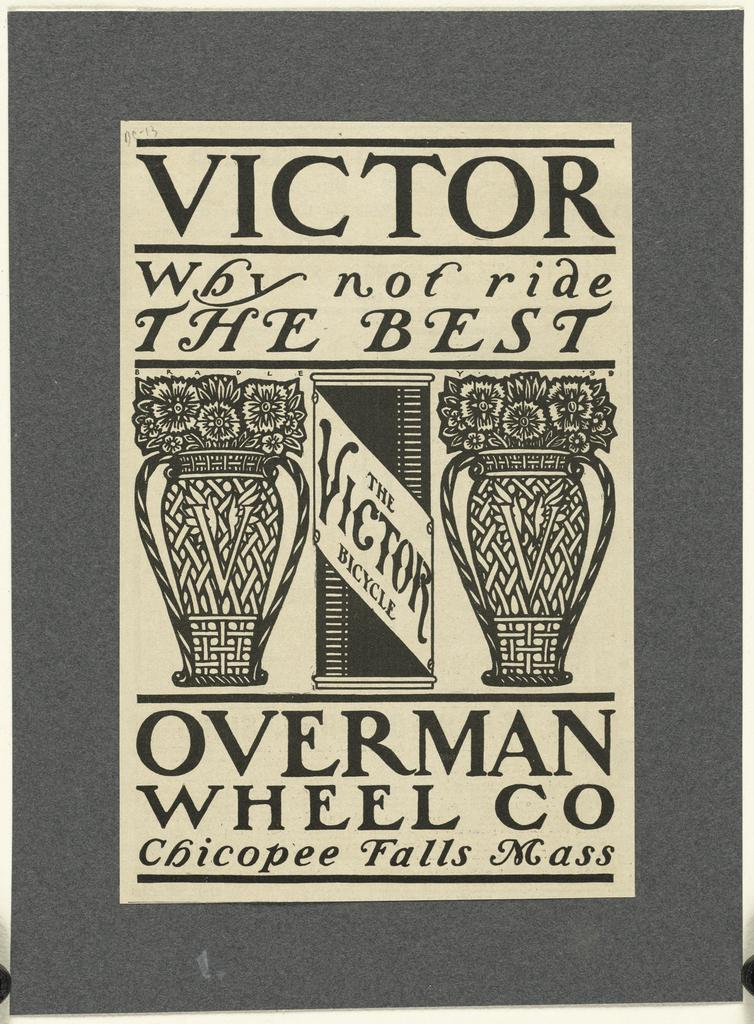What type of visual representation is the image? The image appears to be a poster. What can be seen on the poster? There are images of flower vases on the poster. Is there any text on the poster? Yes, there is writing on the poster. How many ripe berries can be seen on the poster? There are no berries present on the poster; it features images of flower vases and writing. Can you describe the flock of birds flying across the poster? There is no flock of birds depicted on the poster; it only contains images of flower vases and writing. 